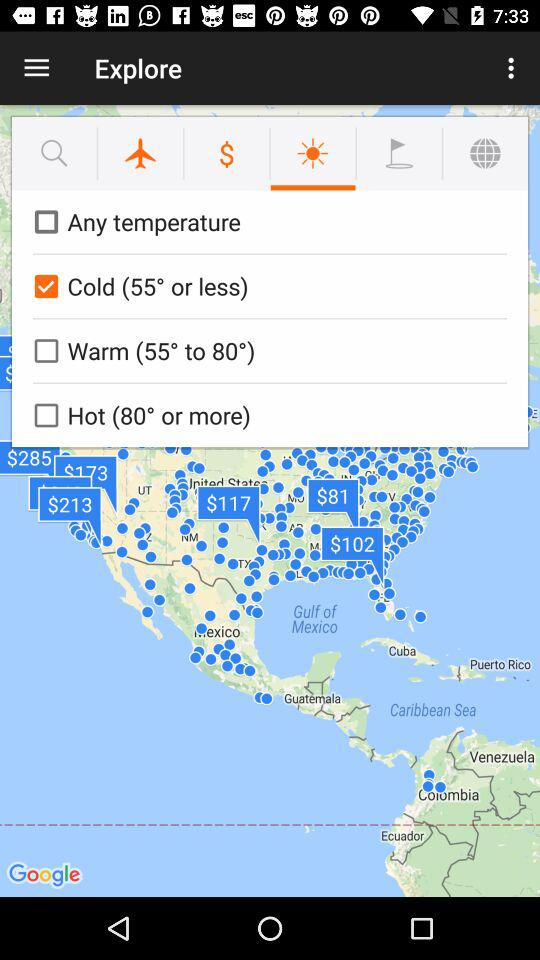Which option for temperature is selected? The selected option for temperature is "Cold (55° or less)". 